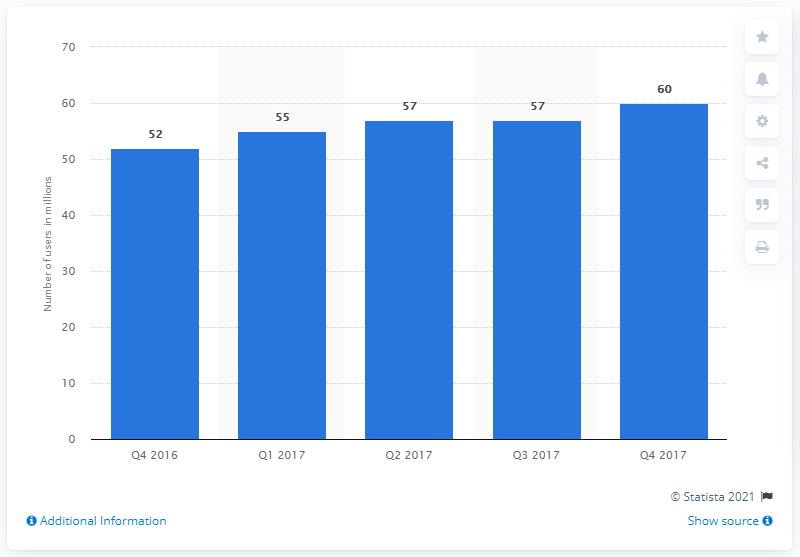Draw attention to some important aspects in this diagram. Snapchat ended 2017 with 60 million monthly active users. Snapchat gained 60 million MAU in Europe from the fourth quarter of 2017 to the fourth quarter of 2017. 